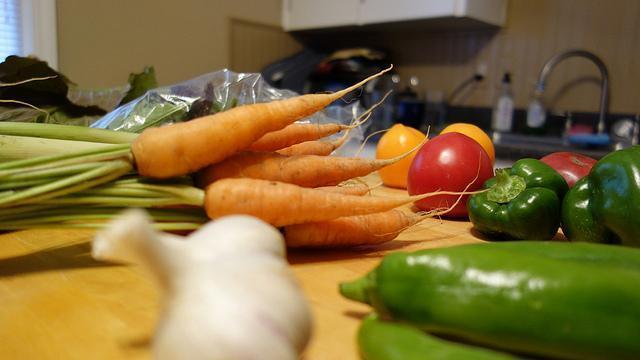How many carrots can be seen?
Give a very brief answer. 4. 